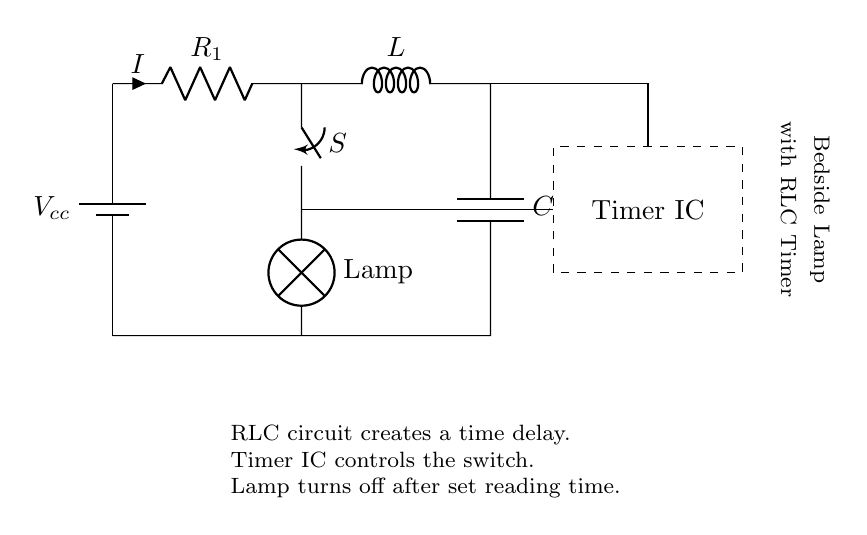What is the main power source in this circuit? The main power source is represented by the battery symbol, labeled as Vcc. This is where the circuit gets its voltage supply.
Answer: Vcc What type of components are present in this circuit? The components in this circuit include a resistor, inductor, capacitor, switch, lamp, and a timer IC. Each component plays a specific role in the circuit's function.
Answer: Resistor, inductor, capacitor, switch, lamp, timer IC What does the lamp do when the timer is activated? The lamp is connected to the switch and it lights up when the switch is closed, signaling that the timer has been activated. Once the timer elapses, the switch opens, and the lamp turns off.
Answer: Lights up What role does the timer IC play in this circuit? The timer IC controls the switch operation based on an internal timing mechanism. It ensures that after a predetermined time set for reading, the lamp is turned off automatically.
Answer: Controls the switch Why is an RLC circuit used in the bedside lamp? The RLC circuit creates a time delay that allows the lamp to remain on for a set reading time and then turn off automatically. This is important for energy savings and convenience.
Answer: Creates a time delay What happens if the inductor is removed from the circuit? Removing the inductor would alter the response time of the circuit significantly, affecting how long the lamp stays on after the timer IC activates. The RLC timing property would be lost.
Answer: Affects timing 